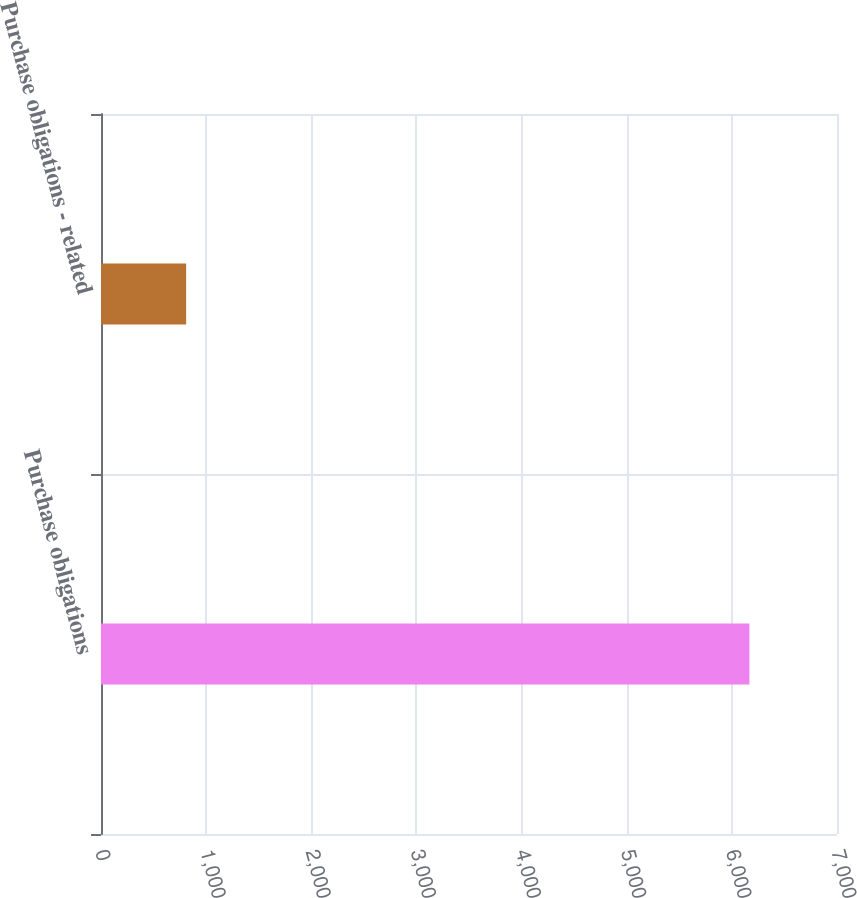Convert chart. <chart><loc_0><loc_0><loc_500><loc_500><bar_chart><fcel>Purchase obligations<fcel>Purchase obligations - related<nl><fcel>6167<fcel>810<nl></chart> 